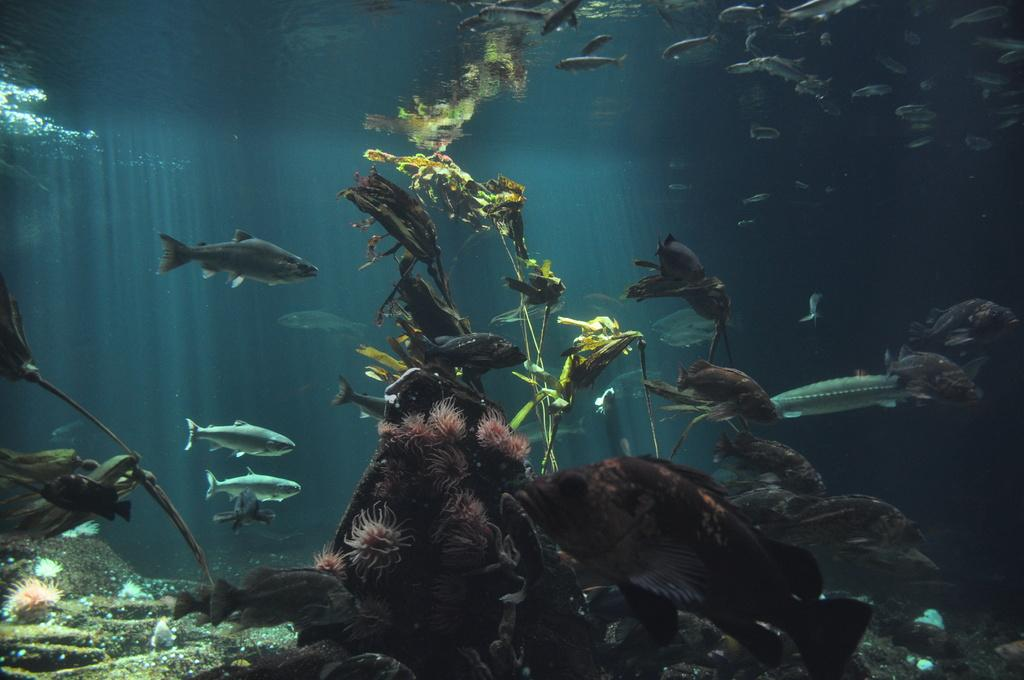What is the main subject in the center of the image? There is water in the center of the image. What can be seen growing in the water? There are underwater plants visible in the image. What types of animals are present in the water? Different types of fishes are present in the image. What is the name of the impulse that causes the fishes to swim in the image? There is no mention of an impulse or any specific behavior of the fishes in the image. 